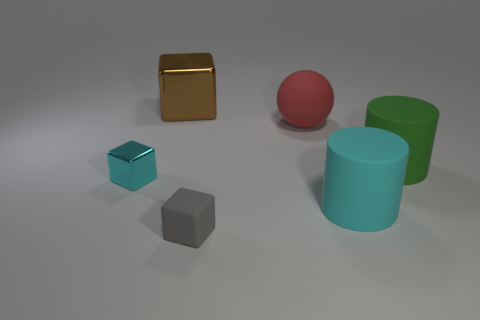Subtract all spheres. How many objects are left? 5 Subtract all gray rubber blocks. How many blocks are left? 2 Subtract 0 yellow cylinders. How many objects are left? 6 Subtract 3 cubes. How many cubes are left? 0 Subtract all gray cubes. Subtract all red spheres. How many cubes are left? 2 Subtract all gray spheres. How many cyan cylinders are left? 1 Subtract all large spheres. Subtract all gray matte things. How many objects are left? 4 Add 4 gray rubber cubes. How many gray rubber cubes are left? 5 Add 3 small gray blocks. How many small gray blocks exist? 4 Add 1 big green matte things. How many objects exist? 7 